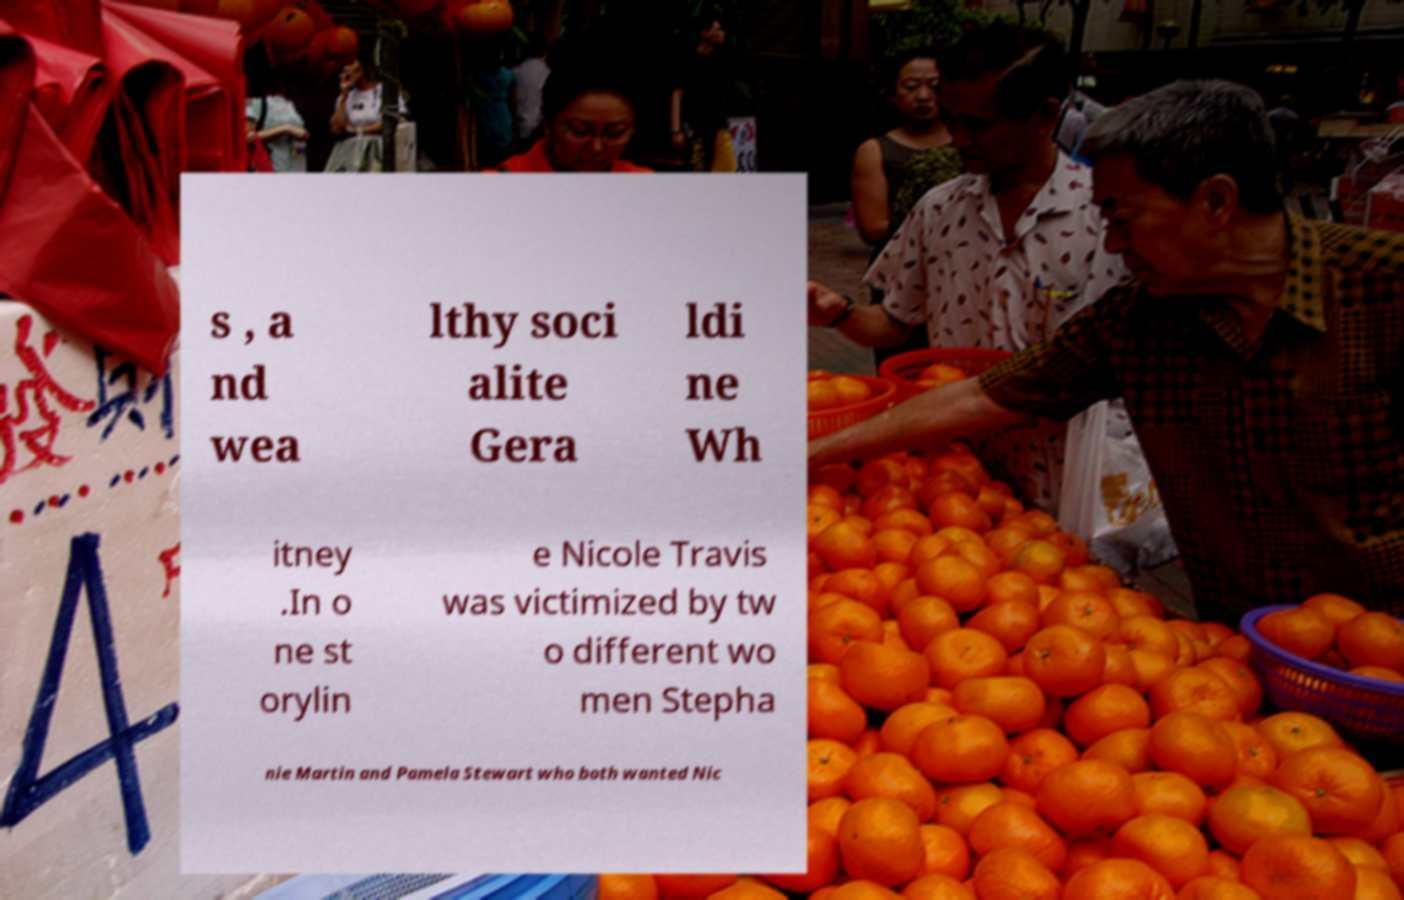What messages or text are displayed in this image? I need them in a readable, typed format. s , a nd wea lthy soci alite Gera ldi ne Wh itney .In o ne st orylin e Nicole Travis was victimized by tw o different wo men Stepha nie Martin and Pamela Stewart who both wanted Nic 